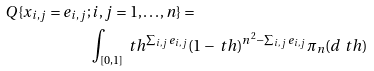Convert formula to latex. <formula><loc_0><loc_0><loc_500><loc_500>Q \{ x _ { i , j } = e _ { i , j } ; & \, i , j = 1 , \dots , n \} = \\ & \int _ { [ 0 , 1 ] } \ t h ^ { \sum _ { i , j } e _ { i , j } } ( 1 - \ t h ) ^ { n ^ { 2 } - \sum _ { i , j } e _ { i , j } } \pi _ { n } ( d \ t h ) \\</formula> 